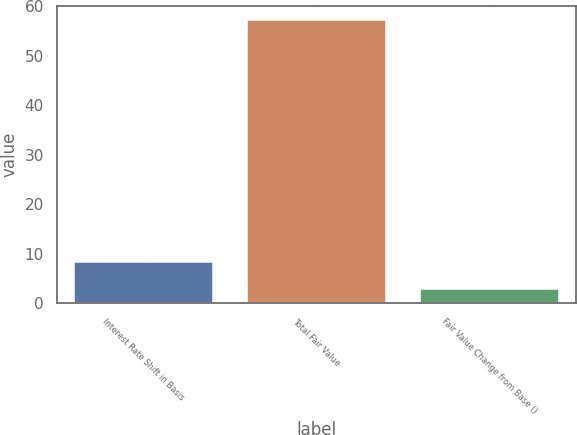Convert chart. <chart><loc_0><loc_0><loc_500><loc_500><bar_chart><fcel>Interest Rate Shift in Basis<fcel>Total Fair Value<fcel>Fair Value Change from Base ()<nl><fcel>8.38<fcel>57.3<fcel>2.95<nl></chart> 